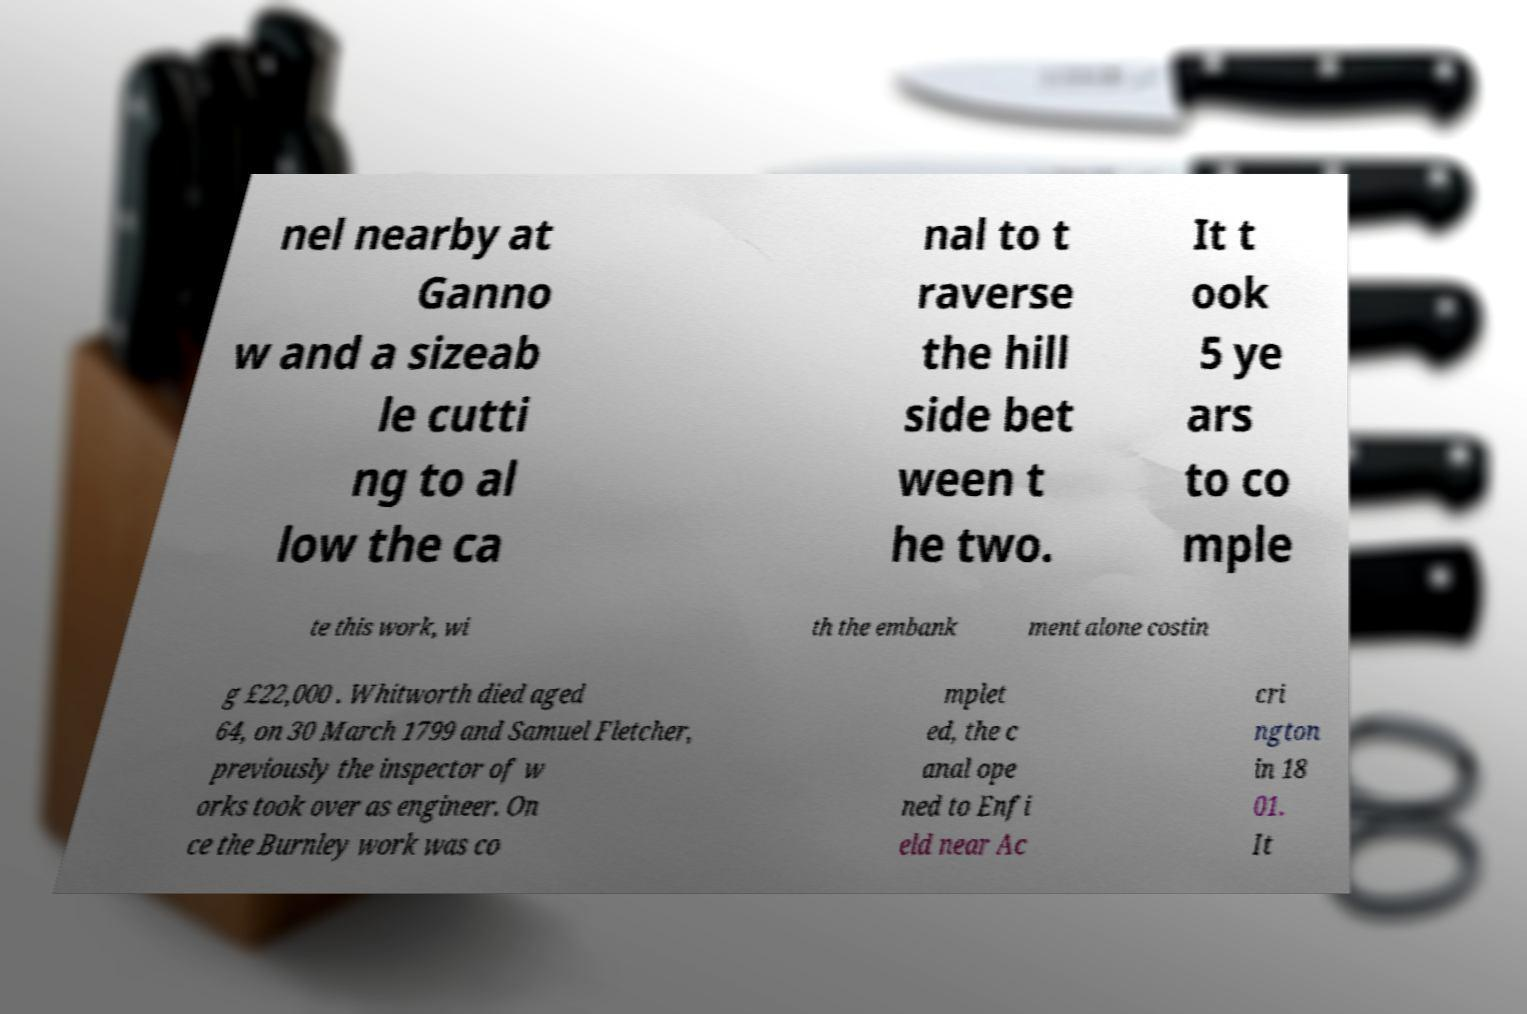There's text embedded in this image that I need extracted. Can you transcribe it verbatim? nel nearby at Ganno w and a sizeab le cutti ng to al low the ca nal to t raverse the hill side bet ween t he two. It t ook 5 ye ars to co mple te this work, wi th the embank ment alone costin g £22,000 . Whitworth died aged 64, on 30 March 1799 and Samuel Fletcher, previously the inspector of w orks took over as engineer. On ce the Burnley work was co mplet ed, the c anal ope ned to Enfi eld near Ac cri ngton in 18 01. It 